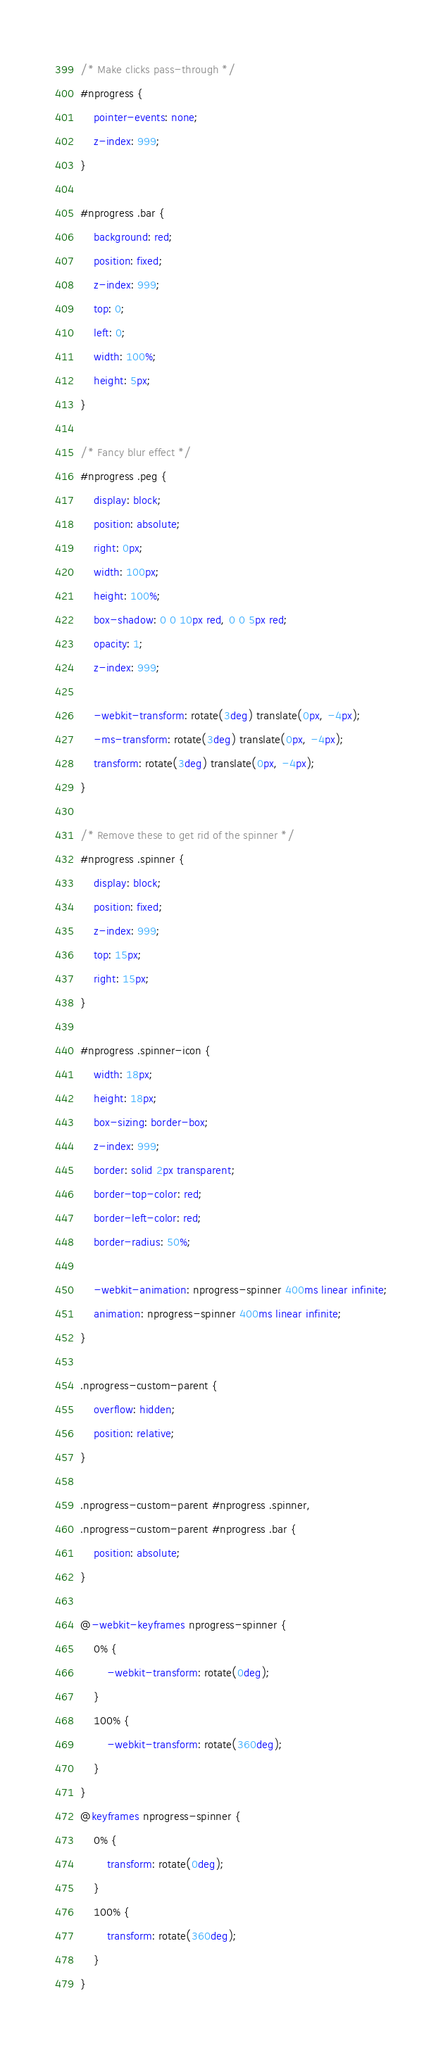<code> <loc_0><loc_0><loc_500><loc_500><_CSS_>/* Make clicks pass-through */
#nprogress {
	pointer-events: none;
	z-index: 999;
}

#nprogress .bar {
	background: red;
	position: fixed;
	z-index: 999;
	top: 0;
	left: 0;
	width: 100%;
	height: 5px;
}

/* Fancy blur effect */
#nprogress .peg {
	display: block;
	position: absolute;
	right: 0px;
	width: 100px;
	height: 100%;
	box-shadow: 0 0 10px red, 0 0 5px red;
	opacity: 1;
	z-index: 999;

	-webkit-transform: rotate(3deg) translate(0px, -4px);
	-ms-transform: rotate(3deg) translate(0px, -4px);
	transform: rotate(3deg) translate(0px, -4px);
}

/* Remove these to get rid of the spinner */
#nprogress .spinner {
	display: block;
	position: fixed;
	z-index: 999;
	top: 15px;
	right: 15px;
}

#nprogress .spinner-icon {
	width: 18px;
	height: 18px;
	box-sizing: border-box;
	z-index: 999;
	border: solid 2px transparent;
	border-top-color: red;
	border-left-color: red;
	border-radius: 50%;

	-webkit-animation: nprogress-spinner 400ms linear infinite;
	animation: nprogress-spinner 400ms linear infinite;
}

.nprogress-custom-parent {
	overflow: hidden;
	position: relative;
}

.nprogress-custom-parent #nprogress .spinner,
.nprogress-custom-parent #nprogress .bar {
	position: absolute;
}

@-webkit-keyframes nprogress-spinner {
	0% {
		-webkit-transform: rotate(0deg);
	}
	100% {
		-webkit-transform: rotate(360deg);
	}
}
@keyframes nprogress-spinner {
	0% {
		transform: rotate(0deg);
	}
	100% {
		transform: rotate(360deg);
	}
}
</code> 